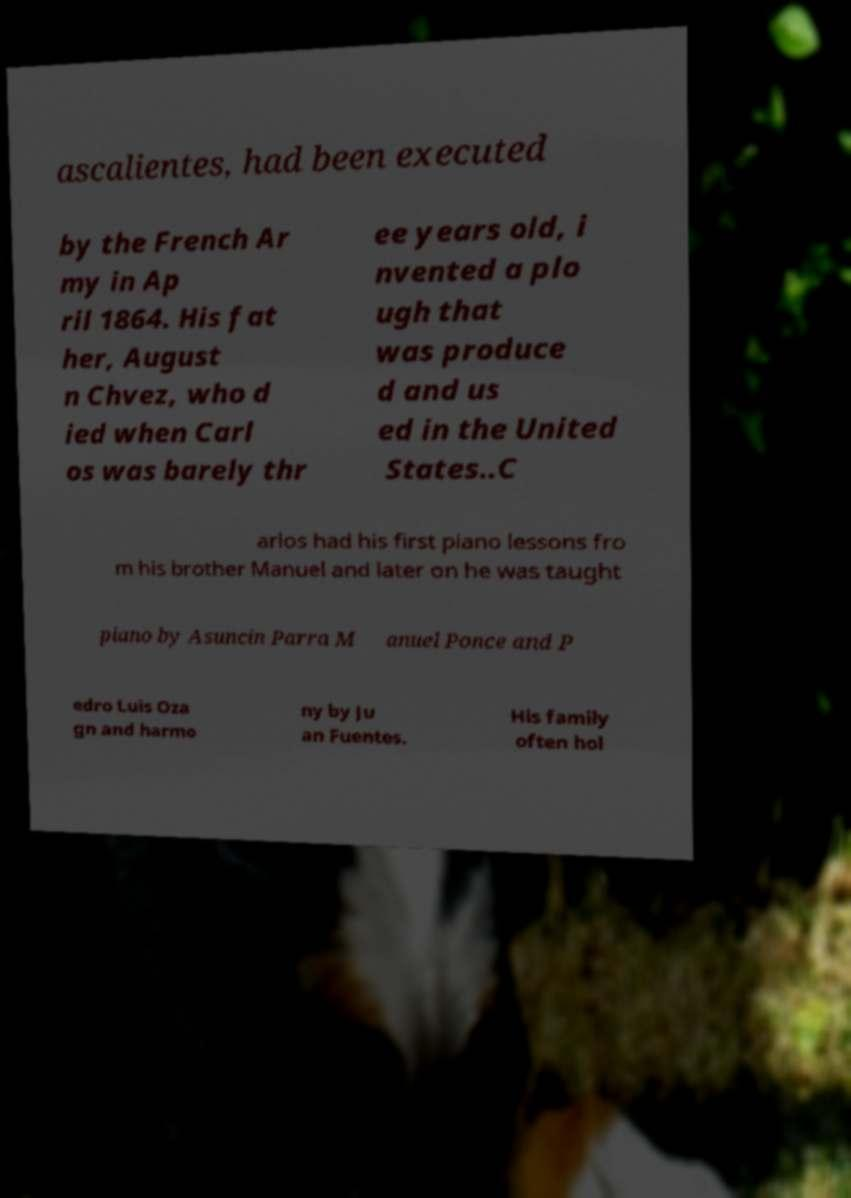For documentation purposes, I need the text within this image transcribed. Could you provide that? ascalientes, had been executed by the French Ar my in Ap ril 1864. His fat her, August n Chvez, who d ied when Carl os was barely thr ee years old, i nvented a plo ugh that was produce d and us ed in the United States..C arlos had his first piano lessons fro m his brother Manuel and later on he was taught piano by Asuncin Parra M anuel Ponce and P edro Luis Oza gn and harmo ny by Ju an Fuentes. His family often hol 